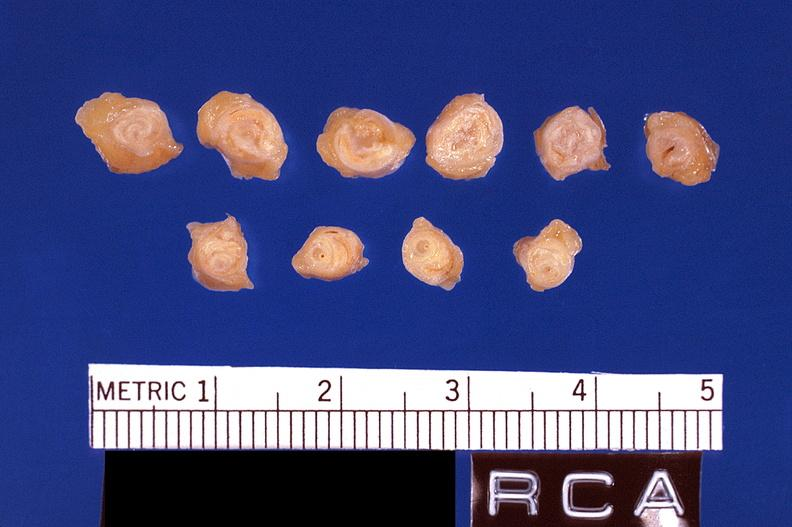does case of peritonitis slide show atherosclerosis, right coronary artery?
Answer the question using a single word or phrase. No 